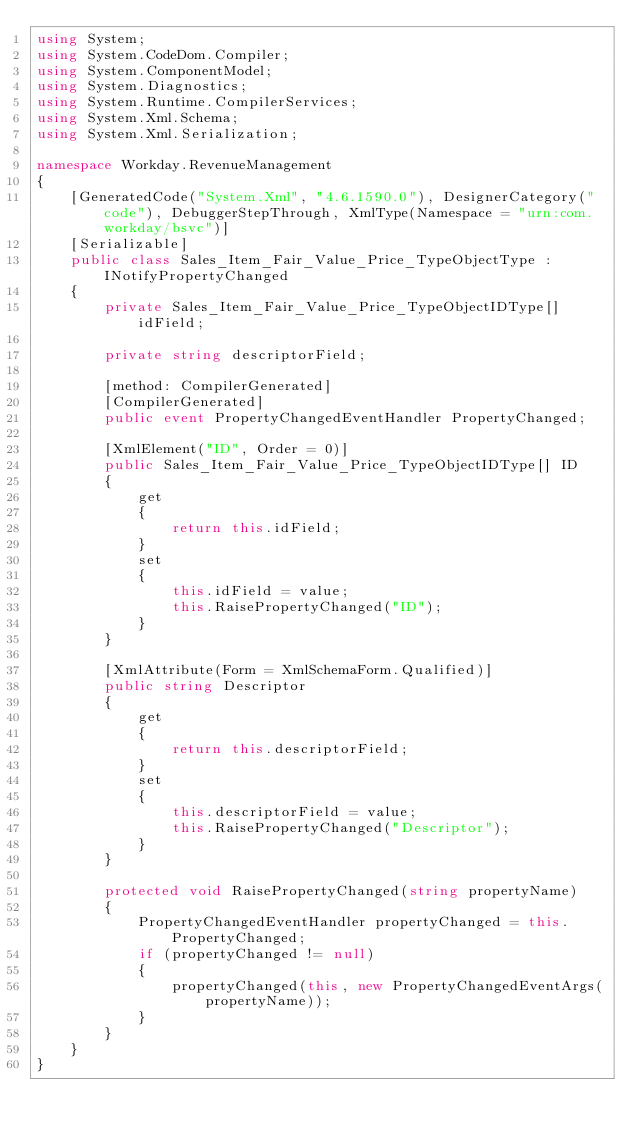Convert code to text. <code><loc_0><loc_0><loc_500><loc_500><_C#_>using System;
using System.CodeDom.Compiler;
using System.ComponentModel;
using System.Diagnostics;
using System.Runtime.CompilerServices;
using System.Xml.Schema;
using System.Xml.Serialization;

namespace Workday.RevenueManagement
{
	[GeneratedCode("System.Xml", "4.6.1590.0"), DesignerCategory("code"), DebuggerStepThrough, XmlType(Namespace = "urn:com.workday/bsvc")]
	[Serializable]
	public class Sales_Item_Fair_Value_Price_TypeObjectType : INotifyPropertyChanged
	{
		private Sales_Item_Fair_Value_Price_TypeObjectIDType[] idField;

		private string descriptorField;

		[method: CompilerGenerated]
		[CompilerGenerated]
		public event PropertyChangedEventHandler PropertyChanged;

		[XmlElement("ID", Order = 0)]
		public Sales_Item_Fair_Value_Price_TypeObjectIDType[] ID
		{
			get
			{
				return this.idField;
			}
			set
			{
				this.idField = value;
				this.RaisePropertyChanged("ID");
			}
		}

		[XmlAttribute(Form = XmlSchemaForm.Qualified)]
		public string Descriptor
		{
			get
			{
				return this.descriptorField;
			}
			set
			{
				this.descriptorField = value;
				this.RaisePropertyChanged("Descriptor");
			}
		}

		protected void RaisePropertyChanged(string propertyName)
		{
			PropertyChangedEventHandler propertyChanged = this.PropertyChanged;
			if (propertyChanged != null)
			{
				propertyChanged(this, new PropertyChangedEventArgs(propertyName));
			}
		}
	}
}
</code> 